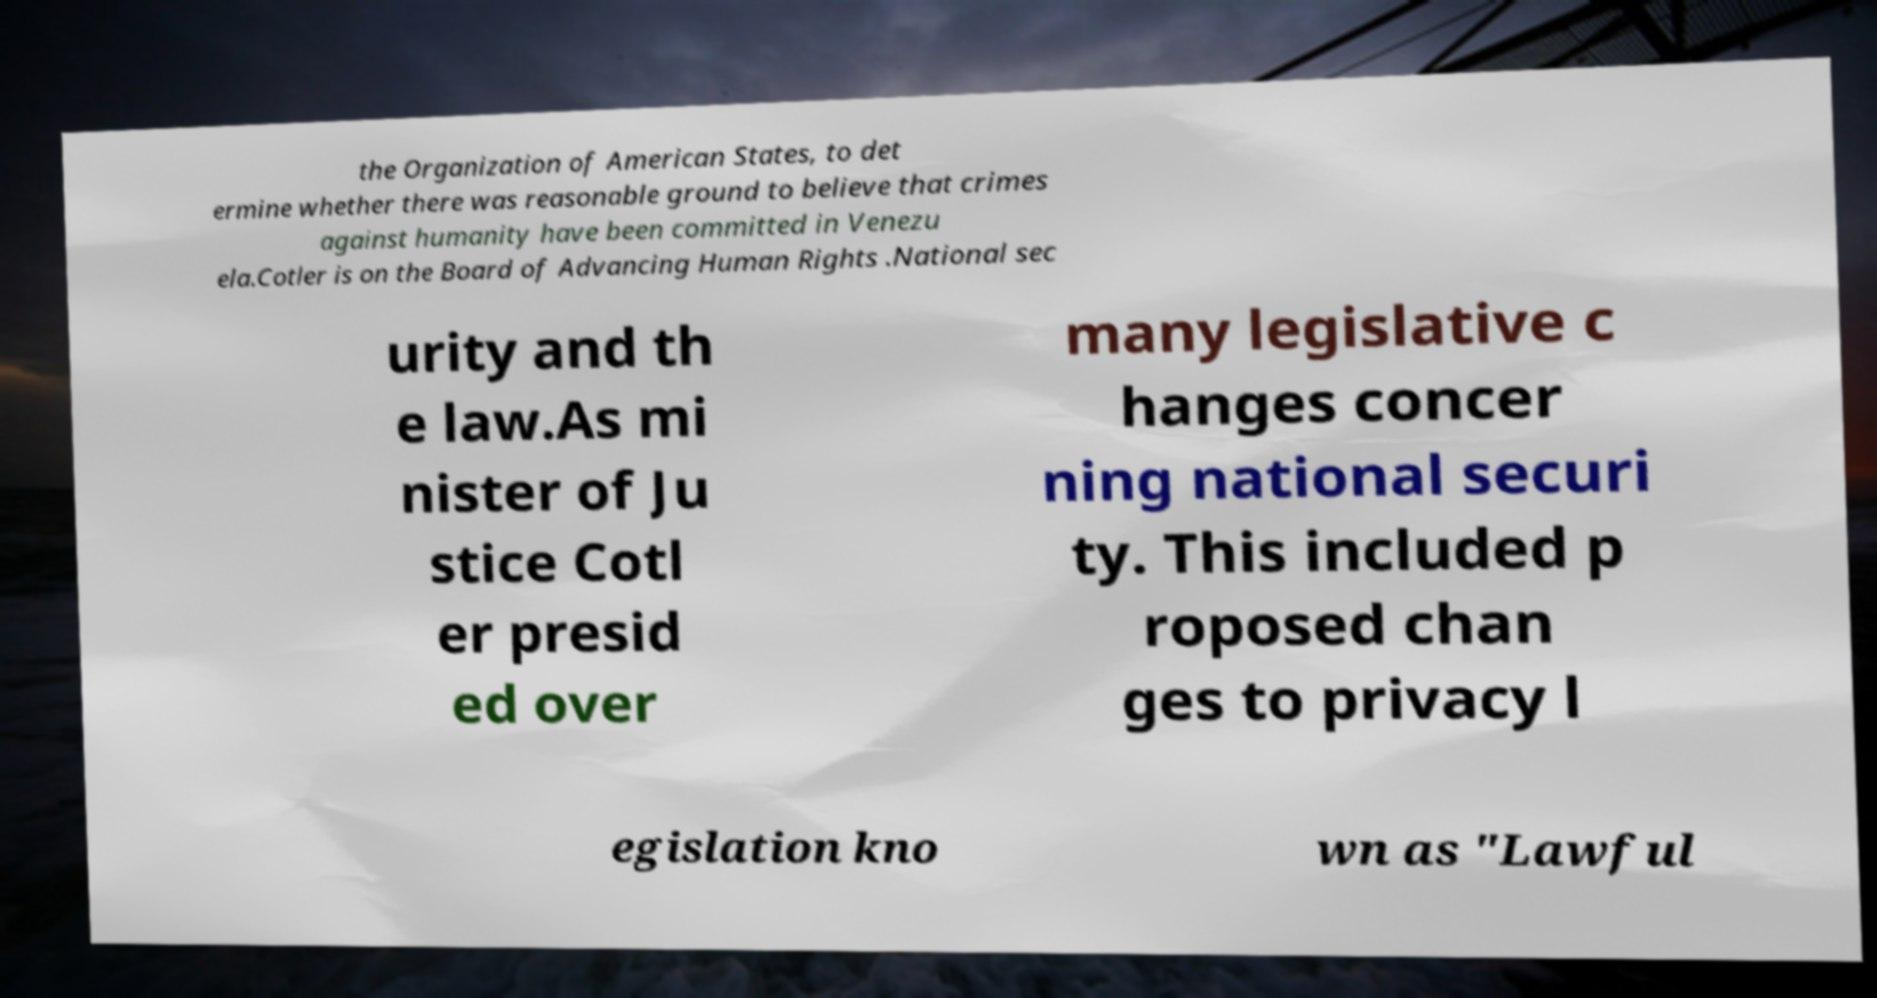Please identify and transcribe the text found in this image. the Organization of American States, to det ermine whether there was reasonable ground to believe that crimes against humanity have been committed in Venezu ela.Cotler is on the Board of Advancing Human Rights .National sec urity and th e law.As mi nister of Ju stice Cotl er presid ed over many legislative c hanges concer ning national securi ty. This included p roposed chan ges to privacy l egislation kno wn as "Lawful 